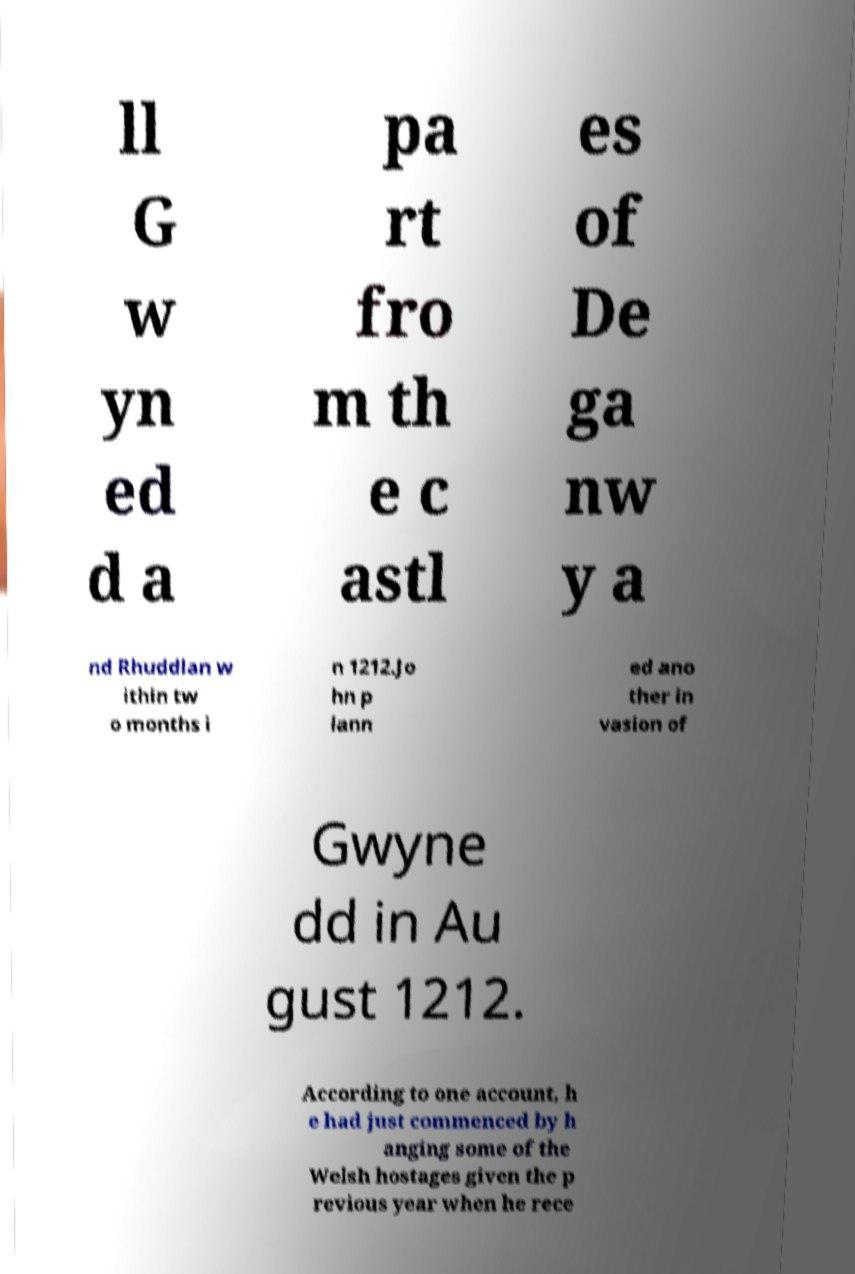Could you extract and type out the text from this image? ll G w yn ed d a pa rt fro m th e c astl es of De ga nw y a nd Rhuddlan w ithin tw o months i n 1212.Jo hn p lann ed ano ther in vasion of Gwyne dd in Au gust 1212. According to one account, h e had just commenced by h anging some of the Welsh hostages given the p revious year when he rece 